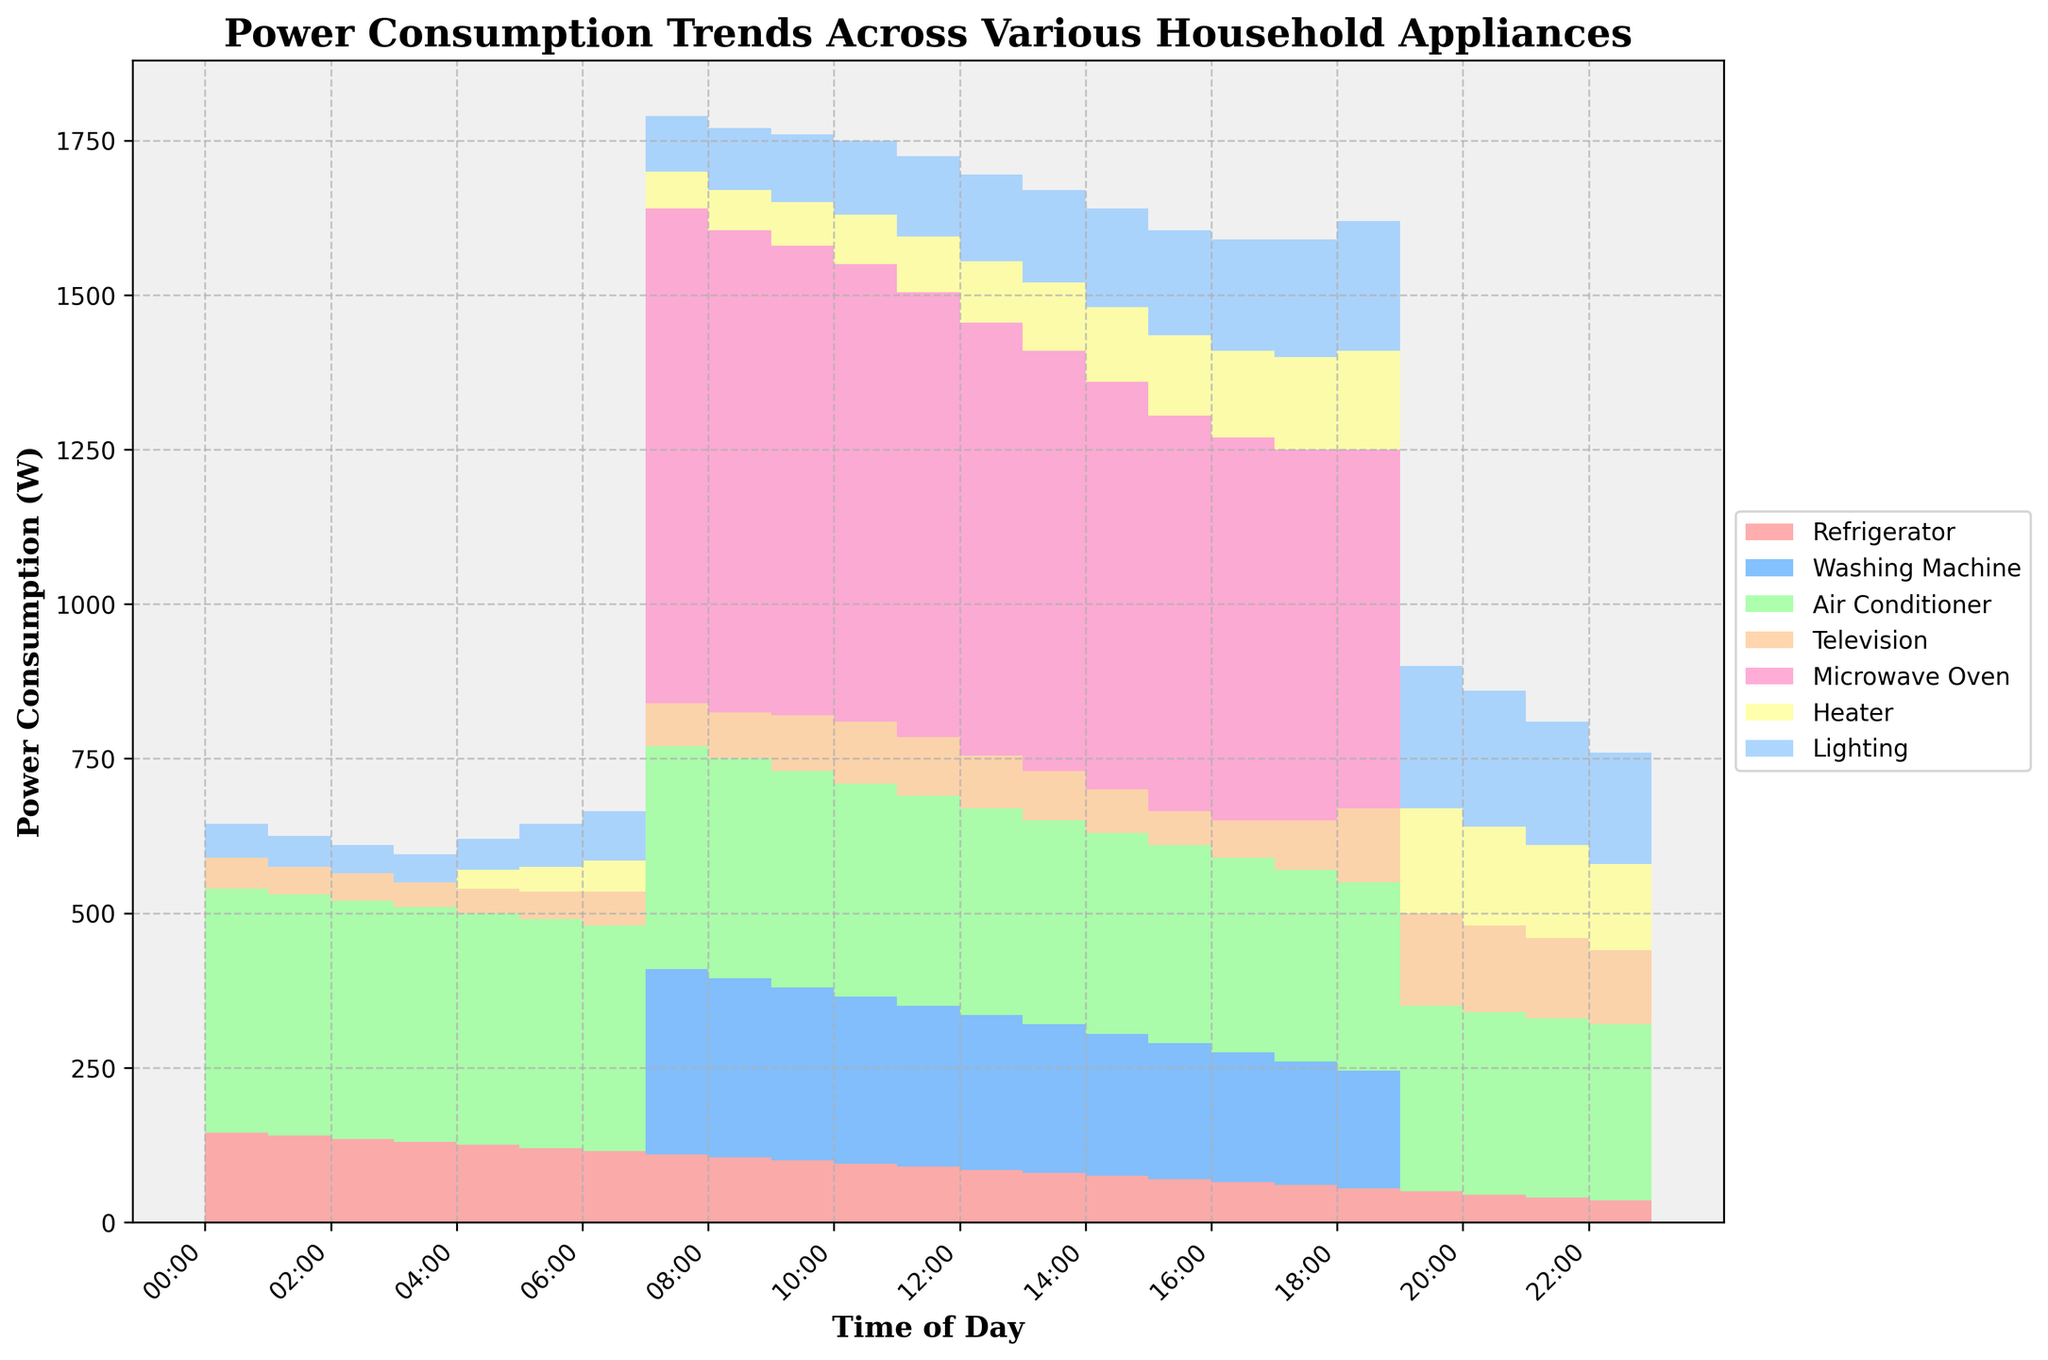What is the title of the plot? The title of the plot is usually located at the top of the figure. In this case, it reads 'Power Consumption Trends Across Various Household Appliances'.
Answer: Power Consumption Trends Across Various Household Appliances During which time period is the power consumption of the Microwave Oven the highest? To determine this, look for the time period where the section representing the Microwave Oven (most likely the pinkish segment) is the tallest. According to the data, this is at 08:00.
Answer: 08:00 Which appliance has the smallest change in power consumption throughout the day? Observe the plot to see which appliance band remains relatively constant. The Refrigerator band (light red) shows a gradual decline but is consistent, unlike other appliances with more variability.
Answer: Refrigerator At what time does power consumption for the Washing Machine start and stop? Check the specific color section for the Washing Machine (light blue). It notably begins at 08:00 and ceases after 19:00.
Answer: Starts at 08:00 and stops after 19:00 Which household appliance consumes the most power overall? By looking at the widest and most consistently high section across the plot, the Air Conditioner (green) appears to have the largest overall area, indicating the highest consumption.
Answer: Air Conditioner When does Lighting consumption peak in the evening? To find this, look for the highest point in the section representing Lighting (probably the lavender or blue). It peaks at 20:00.
Answer: 20:00 How does the power consumption of the Air Conditioner compare to the Television at 14:00? Compare the height of the sections for both appliances at the time indicated. The Air Conditioner (green) is higher than the Television (orange), meaning it consumes more power at that time.
Answer: Air Conditioner is higher than Television What is the total power consumption of Microwave Oven and Air Conditioner at 15:00? To find this, add the values of Microwave Oven (660 W) and Air Conditioner (325 W) at 15:00 from their respective sections. So, 660 + 325 = 985 W.
Answer: 985 W When does the Heater's power consumption start to increase in the morning? Look specifically at the section corresponding to the Heater (yellow). It starts to increase at 05:00.
Answer: 05:00 What time interval has the least total power consumption? This requires observing the step area chart to identify the narrowest section overall. The interval around 04:00 seems to be the least in total height, representing the lowest consumption.
Answer: Around 04:00 